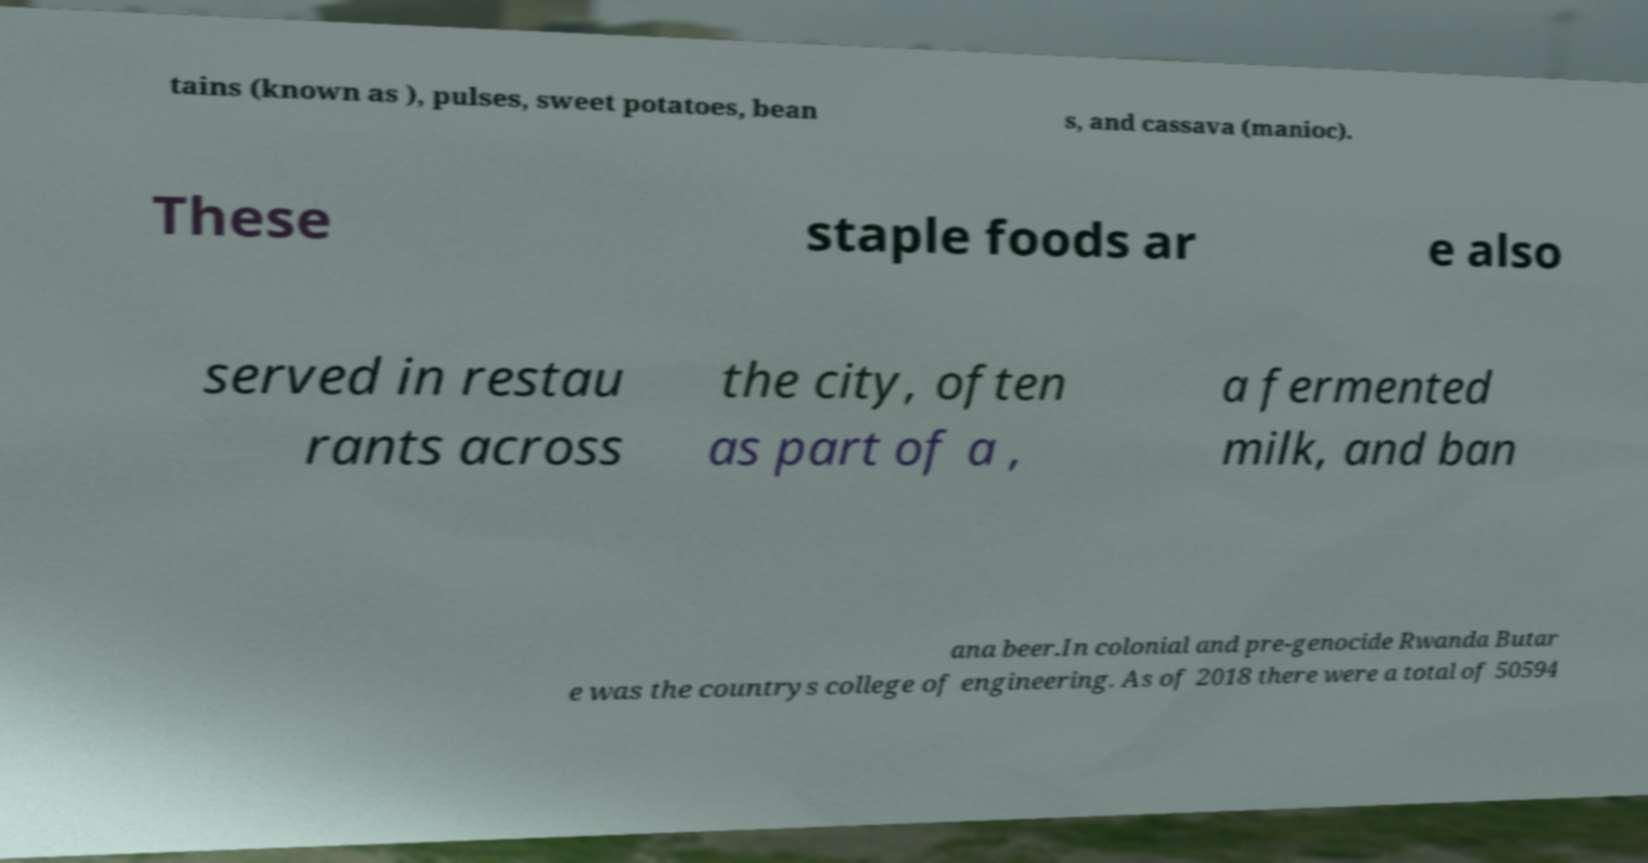Can you accurately transcribe the text from the provided image for me? tains (known as ), pulses, sweet potatoes, bean s, and cassava (manioc). These staple foods ar e also served in restau rants across the city, often as part of a , a fermented milk, and ban ana beer.In colonial and pre-genocide Rwanda Butar e was the countrys college of engineering. As of 2018 there were a total of 50594 